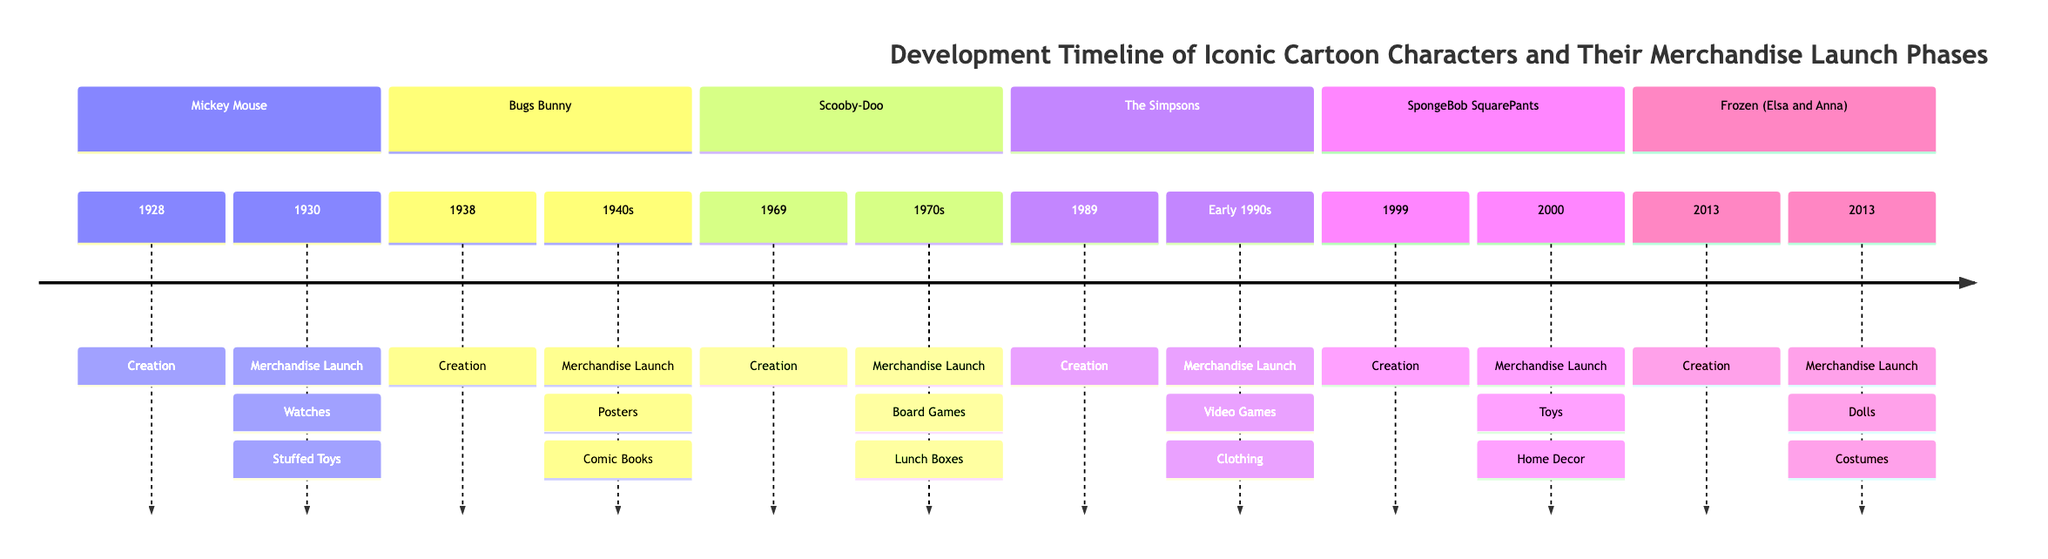What year was Mickey Mouse created? The diagram indicates that Mickey Mouse was created in the year 1928. This is found in the row dedicated to Mickey Mouse, where the creation date is specifically stated.
Answer: 1928 What merchandise launched with Bugs Bunny? The key merchandise items listed for Bugs Bunny include posters and comic books. These are mentioned under the merchandise launch phase for the character.
Answer: Posters, Comic Books Which character had their merchandise launch in 2013? According to the timeline, Frozen (Elsa and Anna) had their merchandise launch in the same year as their creation, which is 2013. This is directly stated in the section for Frozen in the timeline.
Answer: Frozen (Elsa and Anna) How many cartoon characters are shown in the timeline? The timeline features six distinct cartoon characters: Mickey Mouse, Bugs Bunny, Scooby-Doo, The Simpsons, SpongeBob SquarePants, and Frozen (Elsa and Anna). Counting them provides the answer.
Answer: 6 What is the significance of SpongeBob SquarePants in the timeline? The significance stated for SpongeBob SquarePants is that it became one of Nickelodeon’s highest-grossing franchises due to extensive merchandise. This information is provided in the section for SpongeBob SquarePants.
Answer: Highest-grossing franchise Which character was first to achieve widespread merchandise success? The timeline indicates that Mickey Mouse was the first cartoon character to have widespread merchandise success, as stated in the significance section for the character.
Answer: Mickey Mouse What type of merchandise is associated with Scooby-Doo? The key merchandise items for Scooby-Doo listed in the timeline include board games and lunch boxes.
Answer: Board Games, Lunch Boxes In which decade did The Simpsons merchandise launch? The merchandise launch phase for The Simpsons is listed as the early 1990s. This indicates the decade in which their merchandise was launched.
Answer: Early 1990s 